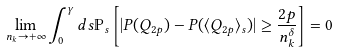Convert formula to latex. <formula><loc_0><loc_0><loc_500><loc_500>\lim _ { n _ { k } \to + \infty } \int _ { 0 } ^ { \gamma } d s \mathbb { P } _ { s } \left [ | P ( Q _ { 2 p } ) - P ( \langle Q _ { 2 p } \rangle _ { s } ) | \geq \frac { 2 p } { n _ { k } ^ { \delta } } \right ] = 0</formula> 